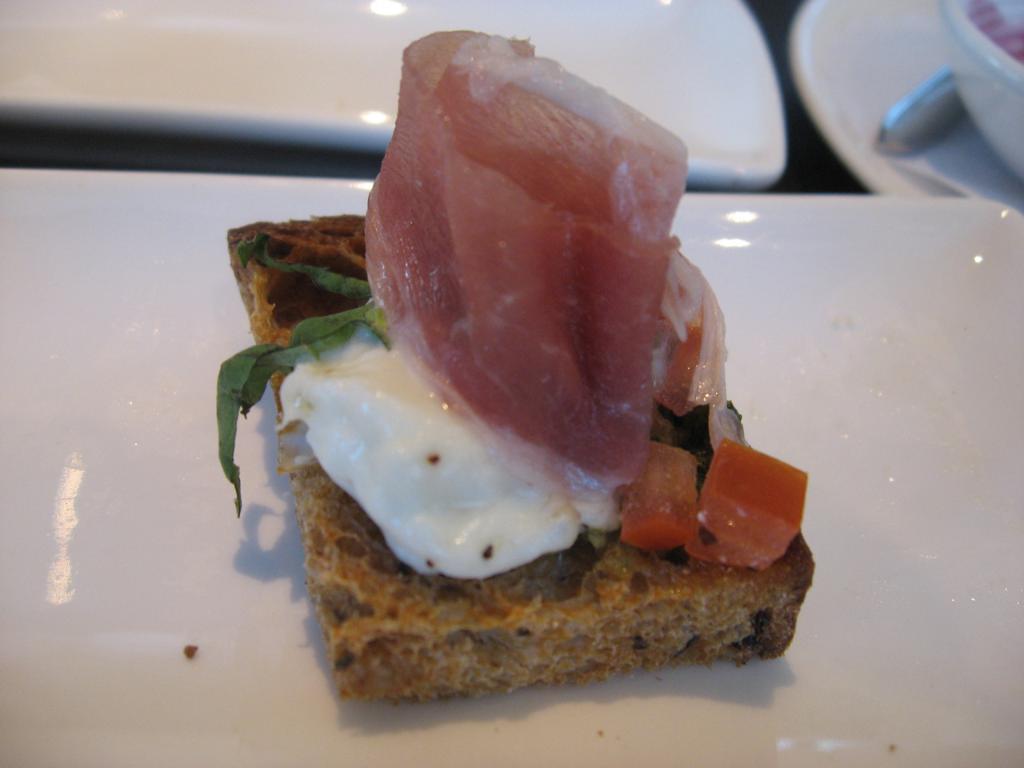Describe this image in one or two sentences. In this picture we can see eatable item is placed on the white color surface. Side we can see some chairs. 